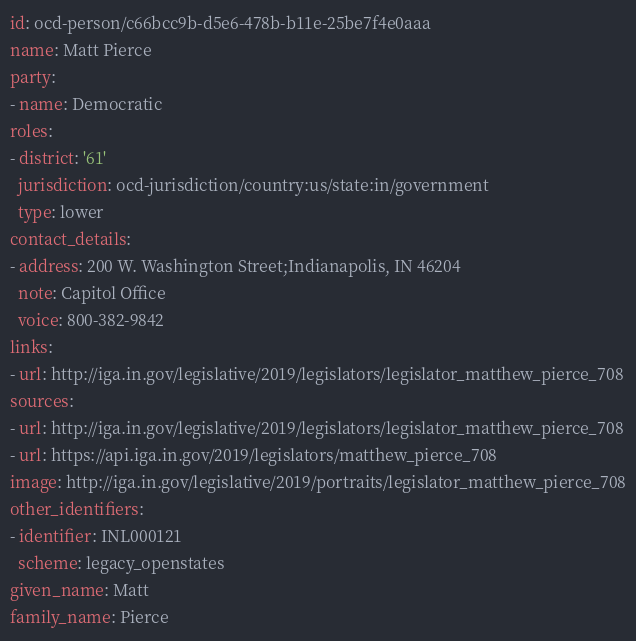<code> <loc_0><loc_0><loc_500><loc_500><_YAML_>id: ocd-person/c66bcc9b-d5e6-478b-b11e-25be7f4e0aaa
name: Matt Pierce
party:
- name: Democratic
roles:
- district: '61'
  jurisdiction: ocd-jurisdiction/country:us/state:in/government
  type: lower
contact_details:
- address: 200 W. Washington Street;Indianapolis, IN 46204
  note: Capitol Office
  voice: 800-382-9842
links:
- url: http://iga.in.gov/legislative/2019/legislators/legislator_matthew_pierce_708
sources:
- url: http://iga.in.gov/legislative/2019/legislators/legislator_matthew_pierce_708
- url: https://api.iga.in.gov/2019/legislators/matthew_pierce_708
image: http://iga.in.gov/legislative/2019/portraits/legislator_matthew_pierce_708
other_identifiers:
- identifier: INL000121
  scheme: legacy_openstates
given_name: Matt
family_name: Pierce
</code> 